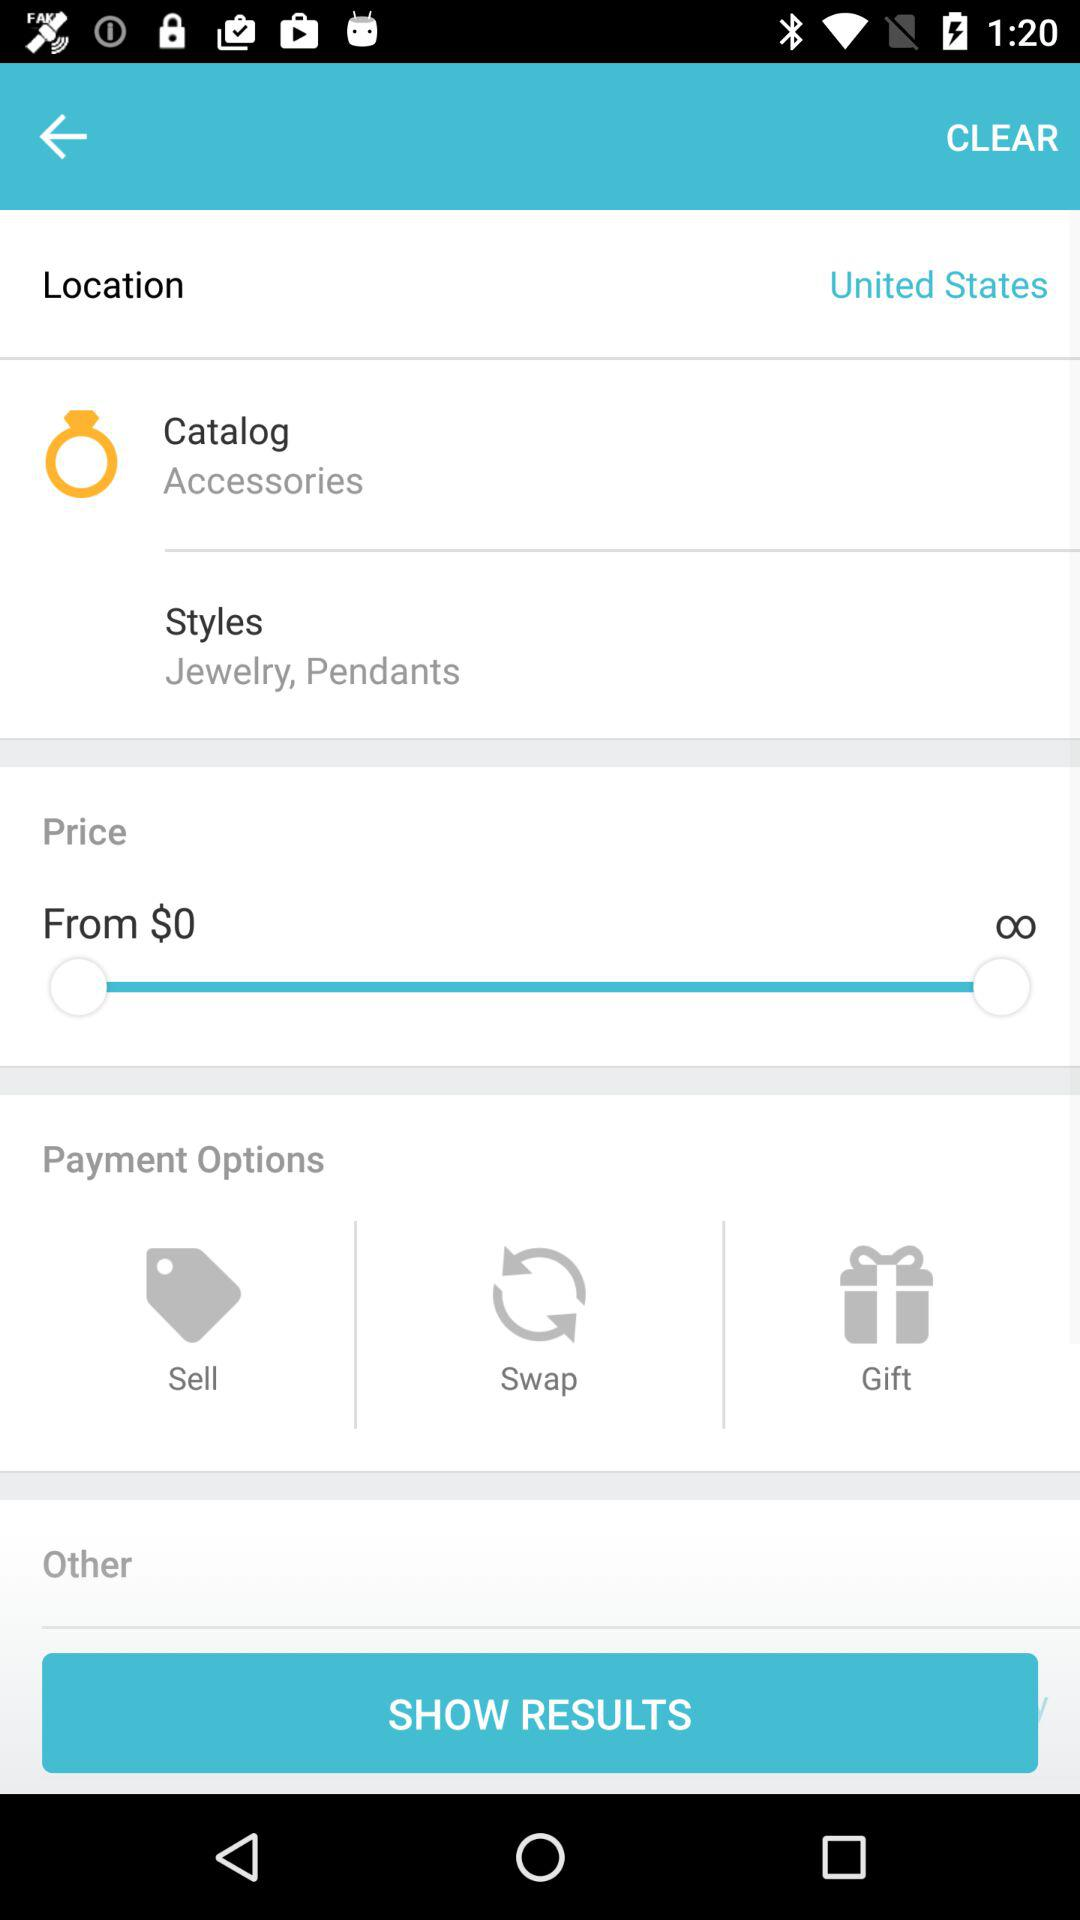What is the price range of the items in this search?
Answer the question using a single word or phrase. $0 - ∞ 